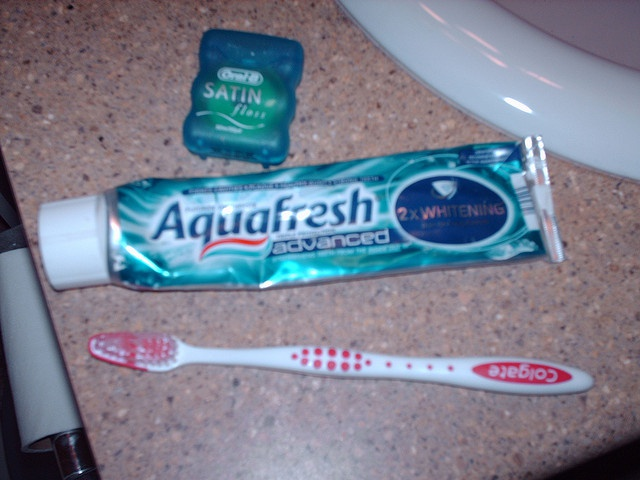Describe the objects in this image and their specific colors. I can see sink in black, darkgray, and gray tones and toothbrush in black, darkgray, lightblue, and lavender tones in this image. 